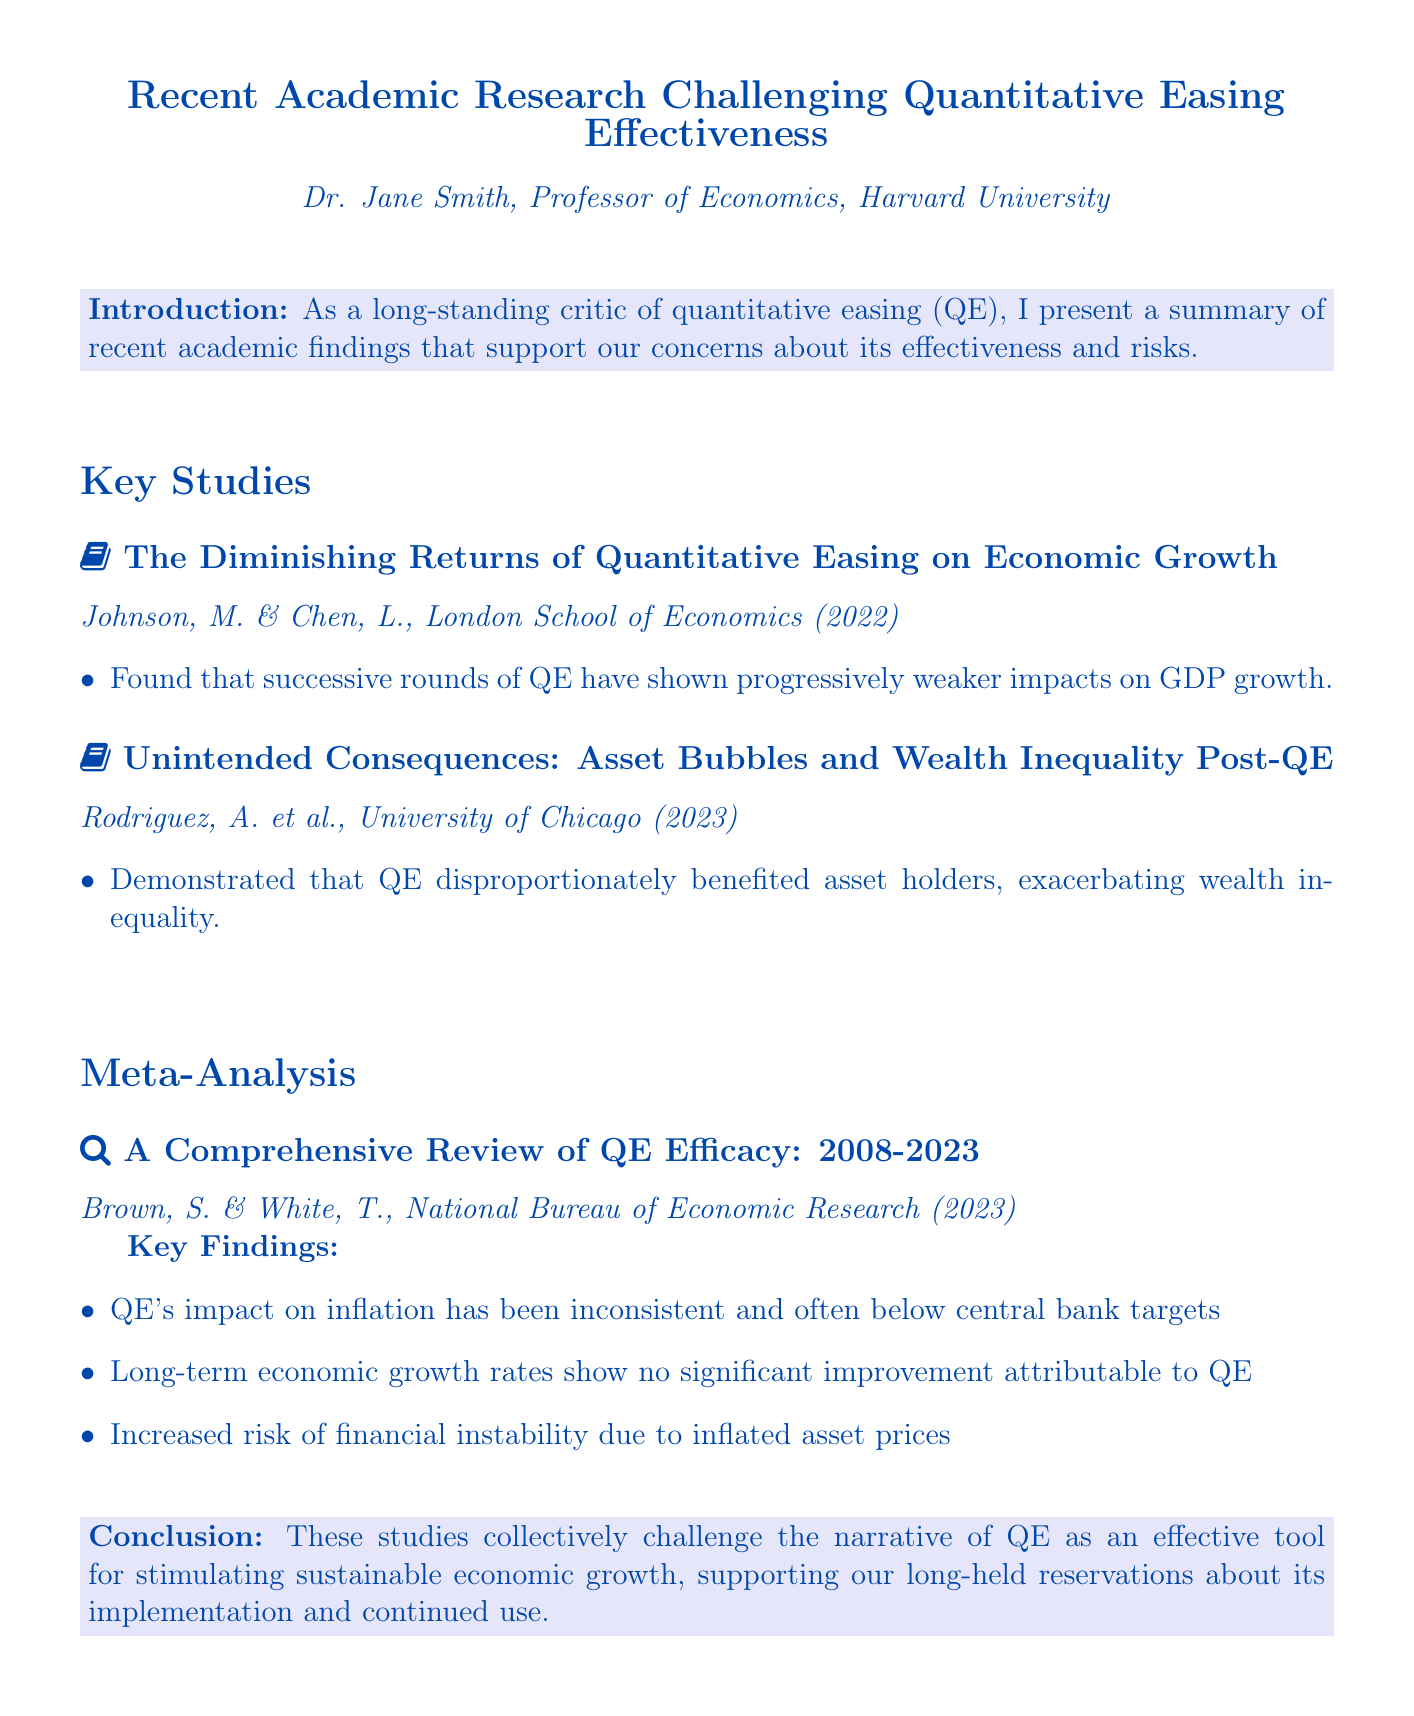What is the title of the document? The title is presented at the start of the document and summarizes the content, which is "Recent Academic Research Challenging Quantitative Easing Effectiveness."
Answer: Recent Academic Research Challenging Quantitative Easing Effectiveness Who authored the document? The document specifies the author in the introductory section, where Dr. Jane Smith is mentioned as the author.
Answer: Dr. Jane Smith When was the study by Johnson and Chen published? The publication year is included in the citation of the study, which states it was published in 2022.
Answer: 2022 What major consequence of QE is mentioned in Rodriguez et al.'s study? The document highlights that Rodriguez et al. found QE led to exacerbating wealth inequality as a consequence.
Answer: Wealth inequality How many studies are listed in the "Key Studies" section? Counting the studies in the "Key Studies" section shows there are two listed.
Answer: 2 What is the name of the meta-analysis study referenced? The document refers to the meta-analysis study titled "A Comprehensive Review of QE Efficacy: 2008-2023."
Answer: A Comprehensive Review of QE Efficacy: 2008-2023 According to the meta-analysis, how have QE's impacts on inflation been characterized? The findings of the meta-analysis indicate that QE's impact on inflation has been described as inconsistent.
Answer: Inconsistent What kind of financial risk is associated with QE as per the meta-analysis? The document states that one risk associated with QE is the increased risk of financial instability.
Answer: Financial instability What is the stated conclusion of the document regarding QE's effectiveness? The conclusion section summarizes the stance that QE is not effective for stimulating sustainable economic growth.
Answer: Not effective 